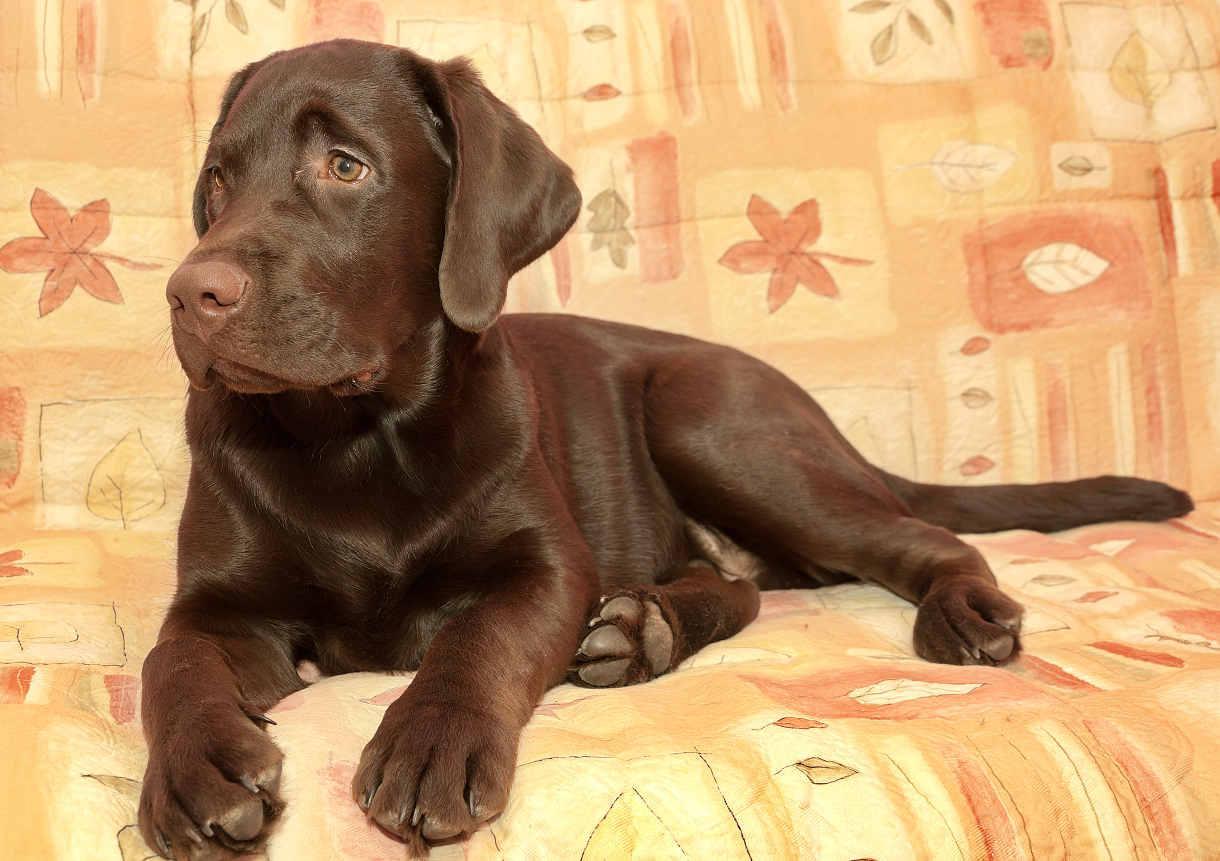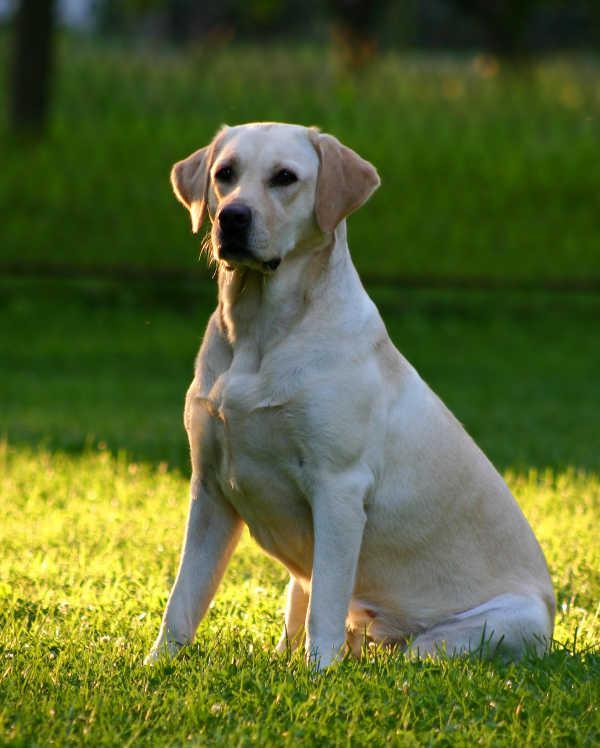The first image is the image on the left, the second image is the image on the right. Considering the images on both sides, is "No dogs have dark fur, one dog is standing on all fours, and at least one dog wears a collar." valid? Answer yes or no. No. The first image is the image on the left, the second image is the image on the right. Evaluate the accuracy of this statement regarding the images: "There is a dog sitting on a grassy lawn". Is it true? Answer yes or no. Yes. 